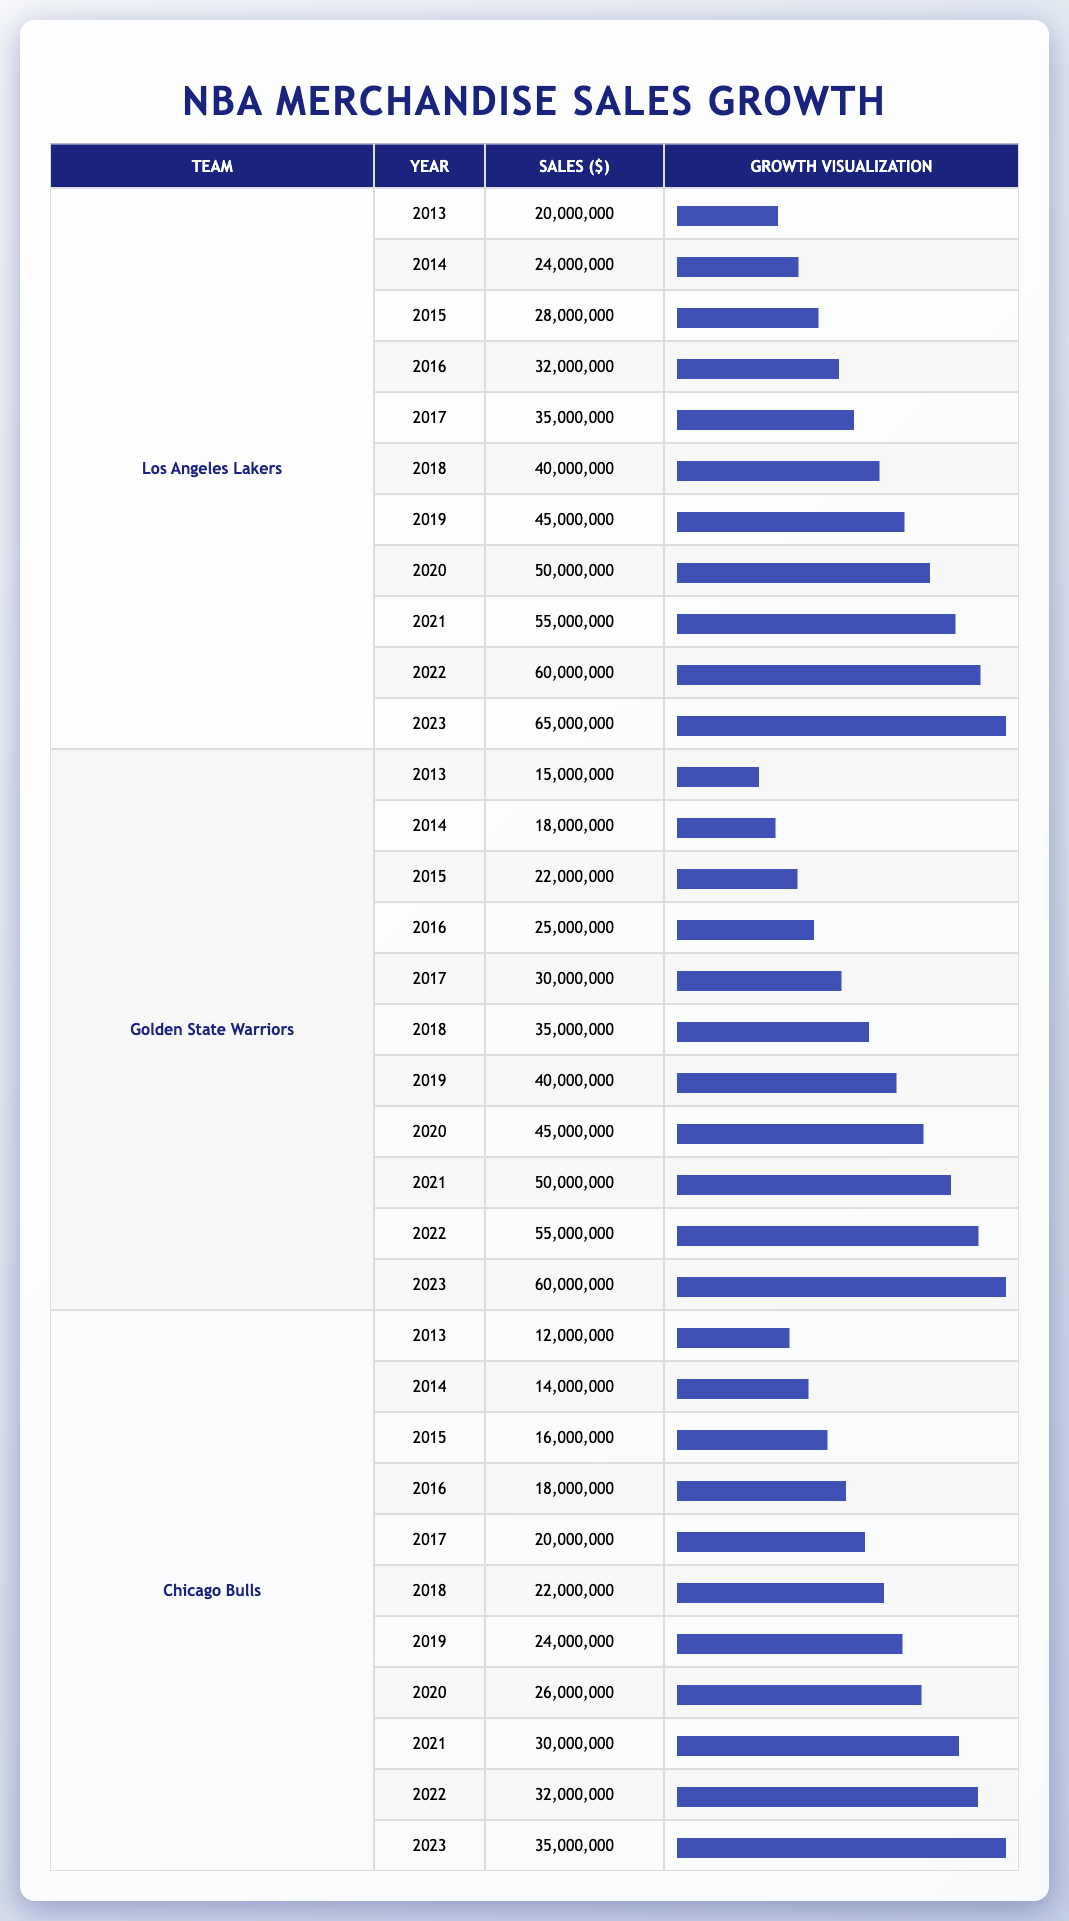What were the merchandise sales for the Golden State Warriors in 2020? From the table, under the row for the Golden State Warriors and the year 2020, the sales value is directly listed as 45,000,000.
Answer: 45,000,000 What is the growth in merchandise sales for the Chicago Bulls from 2013 to 2023? The sales in 2013 were 12,000,000 and in 2023 they were 35,000,000. The growth is calculated by subtracting the two values: 35,000,000 - 12,000,000 = 23,000,000.
Answer: 23,000,000 Did the Los Angeles Lakers see any dip in sales from 2013 to 2023? Looking at the sales data from 2013 to 2023 for the Los Angeles Lakers, the sales consistently increased every year without any decrease, indicating that there was no dip.
Answer: No What was the average merchandise sales for the Golden State Warriors over this period? To find the average, we first sum the sales from 2013 to 2023: (15,000,000 + 18,000,000 + 22,000,000 + 25,000,000 + 30,000,000 + 35,000,000 + 40,000,000 + 45,000,000 + 50,000,000 + 55,000,000 + 60,000,000) which equals  380,000,000. Then divide by 11 (the number of years): 380,000,000 / 11 = 34,545,454.54. Rounding gives approximately 34,545,455.
Answer: 34,545,455 Which team experienced the highest sales in 2023, and what was the amount? By examining the final year (2023), the Los Angeles Lakers had sales of 65,000,000, while the Golden State Warriors had 60,000,000 and the Chicago Bulls had 35,000,000. Hence, the Los Angeles Lakers had the highest sales at this amount.
Answer: Los Angeles Lakers: 65,000,000 